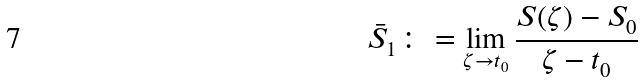<formula> <loc_0><loc_0><loc_500><loc_500>\bar { S } _ { 1 } \colon = \lim _ { \zeta \to t _ { 0 } } \frac { S ( \zeta ) - S _ { 0 } } { \zeta - t _ { 0 } }</formula> 